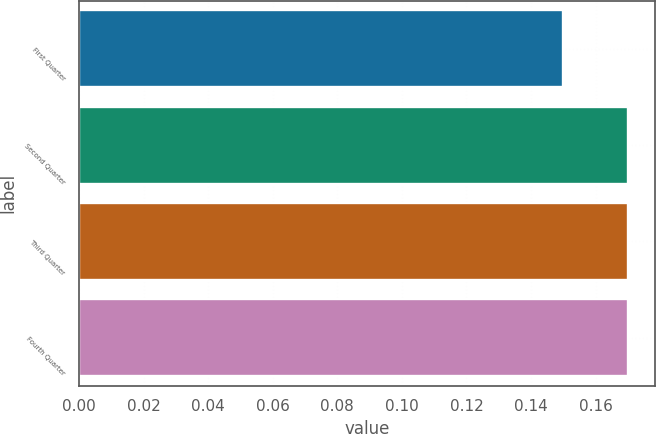Convert chart. <chart><loc_0><loc_0><loc_500><loc_500><bar_chart><fcel>First Quarter<fcel>Second Quarter<fcel>Third Quarter<fcel>Fourth Quarter<nl><fcel>0.15<fcel>0.17<fcel>0.17<fcel>0.17<nl></chart> 